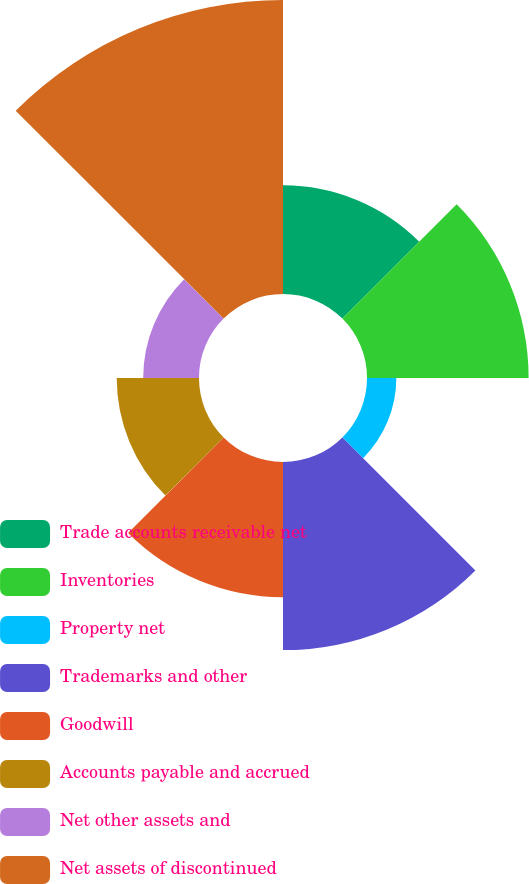<chart> <loc_0><loc_0><loc_500><loc_500><pie_chart><fcel>Trade accounts receivable net<fcel>Inventories<fcel>Property net<fcel>Trademarks and other<fcel>Goodwill<fcel>Accounts payable and accrued<fcel>Net other assets and<fcel>Net assets of discontinued<nl><fcel>10.3%<fcel>15.32%<fcel>2.78%<fcel>17.83%<fcel>12.81%<fcel>7.8%<fcel>5.29%<fcel>27.87%<nl></chart> 